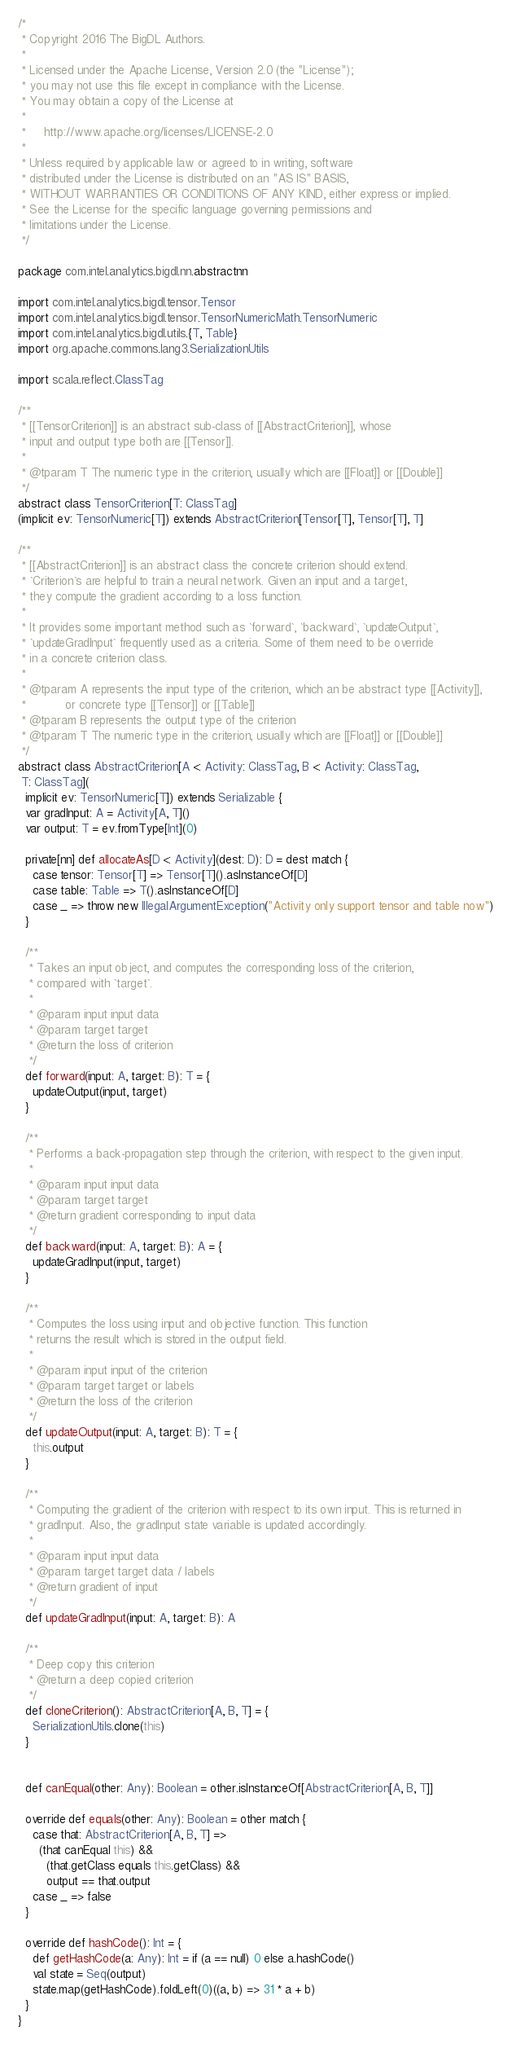<code> <loc_0><loc_0><loc_500><loc_500><_Scala_>/*
 * Copyright 2016 The BigDL Authors.
 *
 * Licensed under the Apache License, Version 2.0 (the "License");
 * you may not use this file except in compliance with the License.
 * You may obtain a copy of the License at
 *
 *     http://www.apache.org/licenses/LICENSE-2.0
 *
 * Unless required by applicable law or agreed to in writing, software
 * distributed under the License is distributed on an "AS IS" BASIS,
 * WITHOUT WARRANTIES OR CONDITIONS OF ANY KIND, either express or implied.
 * See the License for the specific language governing permissions and
 * limitations under the License.
 */

package com.intel.analytics.bigdl.nn.abstractnn

import com.intel.analytics.bigdl.tensor.Tensor
import com.intel.analytics.bigdl.tensor.TensorNumericMath.TensorNumeric
import com.intel.analytics.bigdl.utils.{T, Table}
import org.apache.commons.lang3.SerializationUtils

import scala.reflect.ClassTag

/**
 * [[TensorCriterion]] is an abstract sub-class of [[AbstractCriterion]], whose
 * input and output type both are [[Tensor]].
 *
 * @tparam T The numeric type in the criterion, usually which are [[Float]] or [[Double]]
 */
abstract class TensorCriterion[T: ClassTag]
(implicit ev: TensorNumeric[T]) extends AbstractCriterion[Tensor[T], Tensor[T], T]

/**
 * [[AbstractCriterion]] is an abstract class the concrete criterion should extend.
 * `Criterion`s are helpful to train a neural network. Given an input and a target,
 * they compute the gradient according to a loss function.
 *
 * It provides some important method such as `forward`, `backward`, `updateOutput`,
 * `updateGradInput` frequently used as a criteria. Some of them need to be override
 * in a concrete criterion class.
 *
 * @tparam A represents the input type of the criterion, which an be abstract type [[Activity]],
 *           or concrete type [[Tensor]] or [[Table]]
 * @tparam B represents the output type of the criterion
 * @tparam T The numeric type in the criterion, usually which are [[Float]] or [[Double]]
 */
abstract class AbstractCriterion[A <: Activity: ClassTag, B <: Activity: ClassTag,
 T: ClassTag](
  implicit ev: TensorNumeric[T]) extends Serializable {
  var gradInput: A = Activity[A, T]()
  var output: T = ev.fromType[Int](0)

  private[nn] def allocateAs[D <: Activity](dest: D): D = dest match {
    case tensor: Tensor[T] => Tensor[T]().asInstanceOf[D]
    case table: Table => T().asInstanceOf[D]
    case _ => throw new IllegalArgumentException("Activity only support tensor and table now")
  }

  /**
   * Takes an input object, and computes the corresponding loss of the criterion,
   * compared with `target`.
   *
   * @param input input data
   * @param target target
   * @return the loss of criterion
   */
  def forward(input: A, target: B): T = {
    updateOutput(input, target)
  }

  /**
   * Performs a back-propagation step through the criterion, with respect to the given input.
   *
   * @param input input data
   * @param target target
   * @return gradient corresponding to input data
   */
  def backward(input: A, target: B): A = {
    updateGradInput(input, target)
  }

  /**
   * Computes the loss using input and objective function. This function
   * returns the result which is stored in the output field.
   *
   * @param input input of the criterion
   * @param target target or labels
   * @return the loss of the criterion
   */
  def updateOutput(input: A, target: B): T = {
    this.output
  }

  /**
   * Computing the gradient of the criterion with respect to its own input. This is returned in
   * gradInput. Also, the gradInput state variable is updated accordingly.
   *
   * @param input input data
   * @param target target data / labels
   * @return gradient of input
   */
  def updateGradInput(input: A, target: B): A

  /**
   * Deep copy this criterion
   * @return a deep copied criterion
   */
  def cloneCriterion(): AbstractCriterion[A, B, T] = {
    SerializationUtils.clone(this)
  }


  def canEqual(other: Any): Boolean = other.isInstanceOf[AbstractCriterion[A, B, T]]

  override def equals(other: Any): Boolean = other match {
    case that: AbstractCriterion[A, B, T] =>
      (that canEqual this) &&
        (that.getClass equals this.getClass) &&
        output == that.output
    case _ => false
  }

  override def hashCode(): Int = {
    def getHashCode(a: Any): Int = if (a == null) 0 else a.hashCode()
    val state = Seq(output)
    state.map(getHashCode).foldLeft(0)((a, b) => 31 * a + b)
  }
}
</code> 